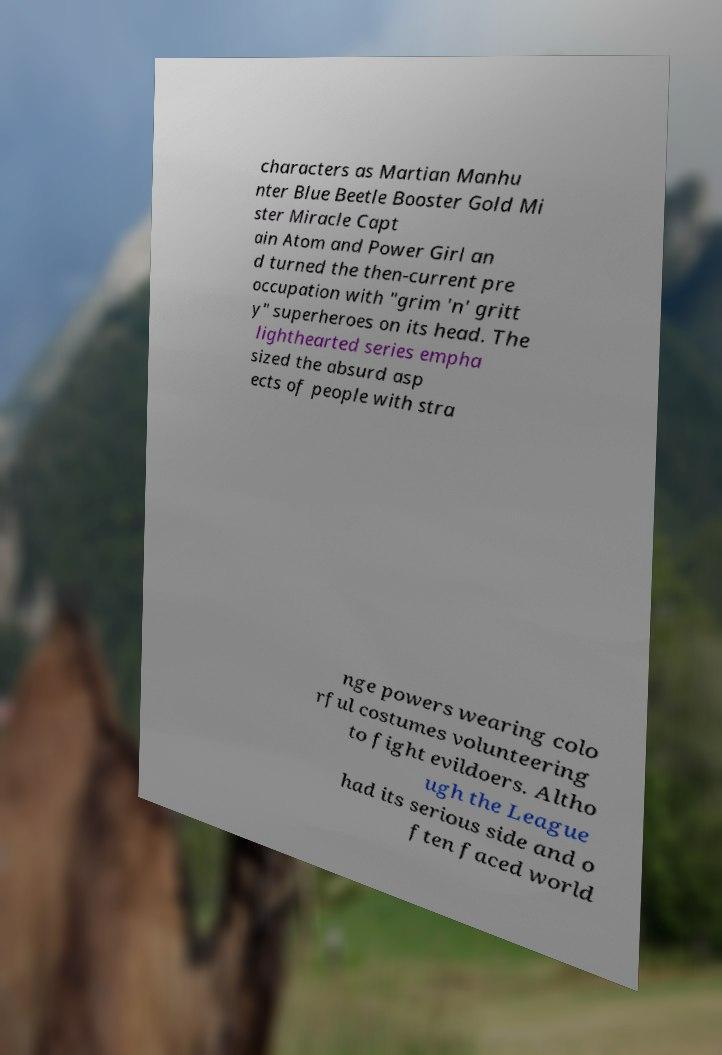For documentation purposes, I need the text within this image transcribed. Could you provide that? characters as Martian Manhu nter Blue Beetle Booster Gold Mi ster Miracle Capt ain Atom and Power Girl an d turned the then-current pre occupation with "grim 'n' gritt y" superheroes on its head. The lighthearted series empha sized the absurd asp ects of people with stra nge powers wearing colo rful costumes volunteering to fight evildoers. Altho ugh the League had its serious side and o ften faced world 